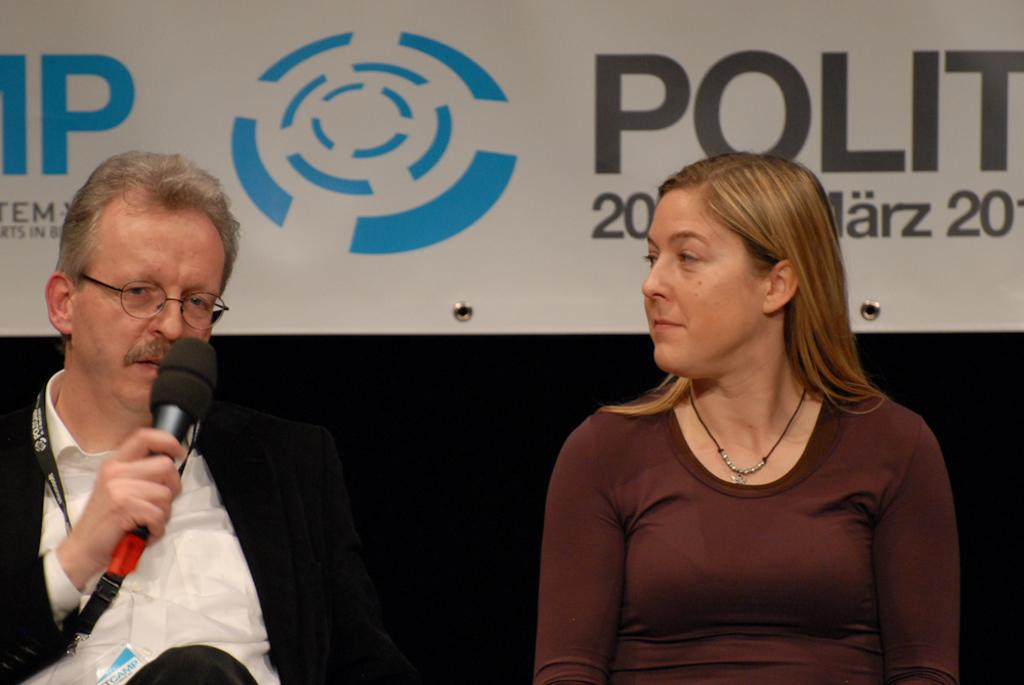What is the person on the left side of the image holding? The person is holding a mic in the image. Who is standing beside the person holding the mic? There is a lady beside the person holding the mic. What can be seen in the background of the image? There is a banner with some text in the background of the image. What sense does the bat use to navigate in the image? There is no bat present in the image, so it is not possible to determine which sense it might use to navigate. 